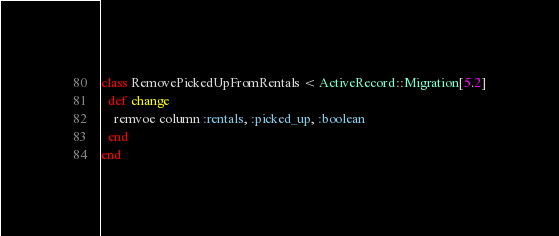<code> <loc_0><loc_0><loc_500><loc_500><_Ruby_>class RemovePickedUpFromRentals < ActiveRecord::Migration[5.2]
  def change
    remvoe column :rentals, :picked_up, :boolean
  end
end
</code> 